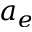Convert formula to latex. <formula><loc_0><loc_0><loc_500><loc_500>a _ { e }</formula> 